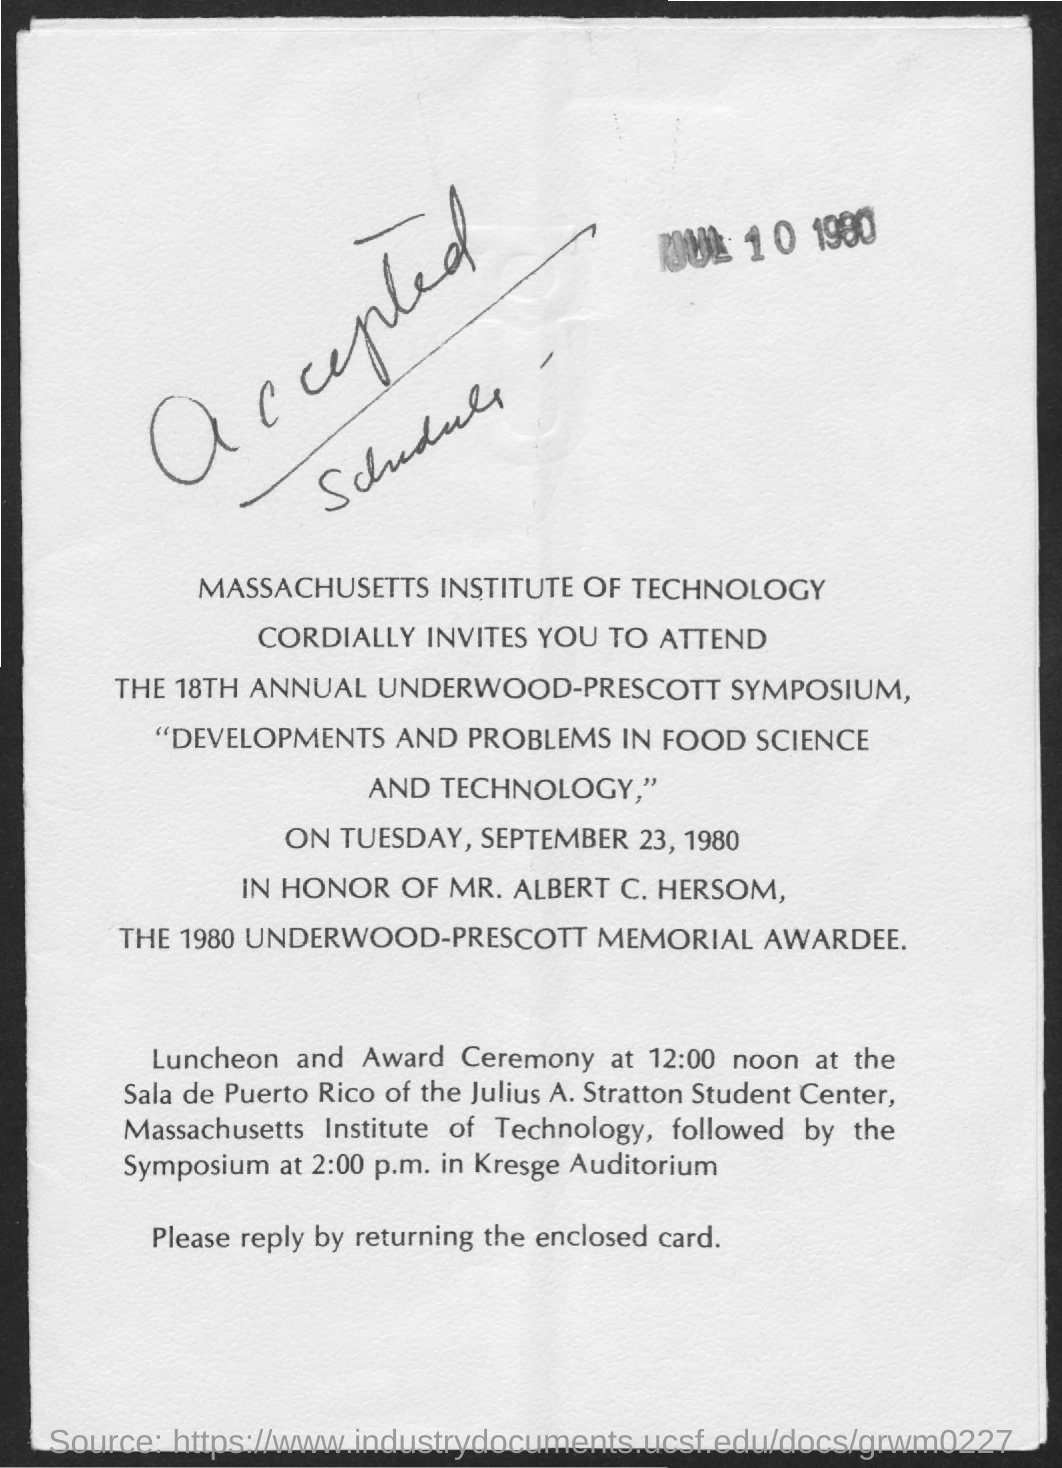Specify some key components in this picture. The luncheon and award ceremony will take place at 12:00 noon. The letter contains handwritten text that reads 'Accepted Schedule...' 